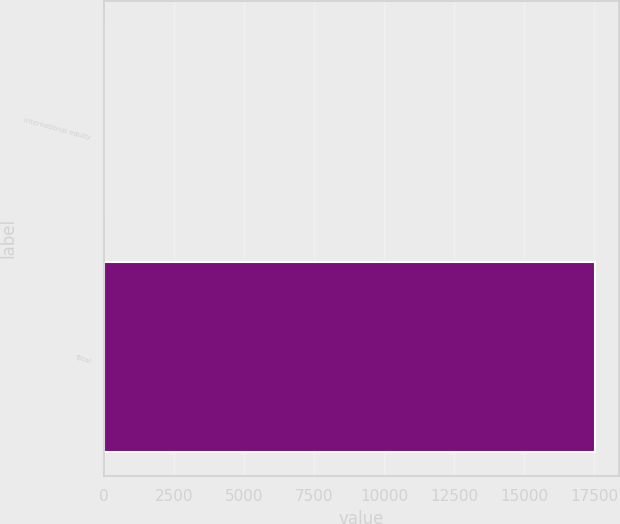<chart> <loc_0><loc_0><loc_500><loc_500><bar_chart><fcel>International equity<fcel>Total<nl><fcel>15<fcel>17527<nl></chart> 